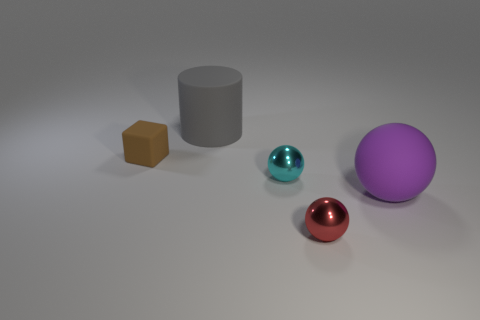Subtract all small shiny balls. How many balls are left? 1 Add 1 small blue blocks. How many objects exist? 6 Subtract all balls. How many objects are left? 2 Subtract all metallic spheres. Subtract all large shiny blocks. How many objects are left? 3 Add 5 brown rubber cubes. How many brown rubber cubes are left? 6 Add 5 cyan things. How many cyan things exist? 6 Subtract all red spheres. How many spheres are left? 2 Subtract 1 cyan balls. How many objects are left? 4 Subtract 2 balls. How many balls are left? 1 Subtract all yellow spheres. Subtract all brown cylinders. How many spheres are left? 3 